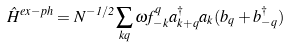Convert formula to latex. <formula><loc_0><loc_0><loc_500><loc_500>\hat { H } ^ { e x - p h } = N ^ { - 1 / 2 } \sum _ { k q } \omega f _ { - k } ^ { q } a _ { k + q } ^ { \dagger } a _ { k } ( b _ { q } + b _ { - q } ^ { \dagger } )</formula> 